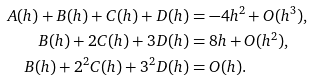<formula> <loc_0><loc_0><loc_500><loc_500>A ( h ) + B ( h ) + C ( h ) + D ( h ) & = - 4 h ^ { 2 } + O ( h ^ { 3 } ) , \\ B ( h ) + 2 C ( h ) + 3 D ( h ) & = 8 h + O ( h ^ { 2 } ) , \, \\ B ( h ) + 2 ^ { 2 } C ( h ) + 3 ^ { 2 } D ( h ) & = O ( h ) .</formula> 